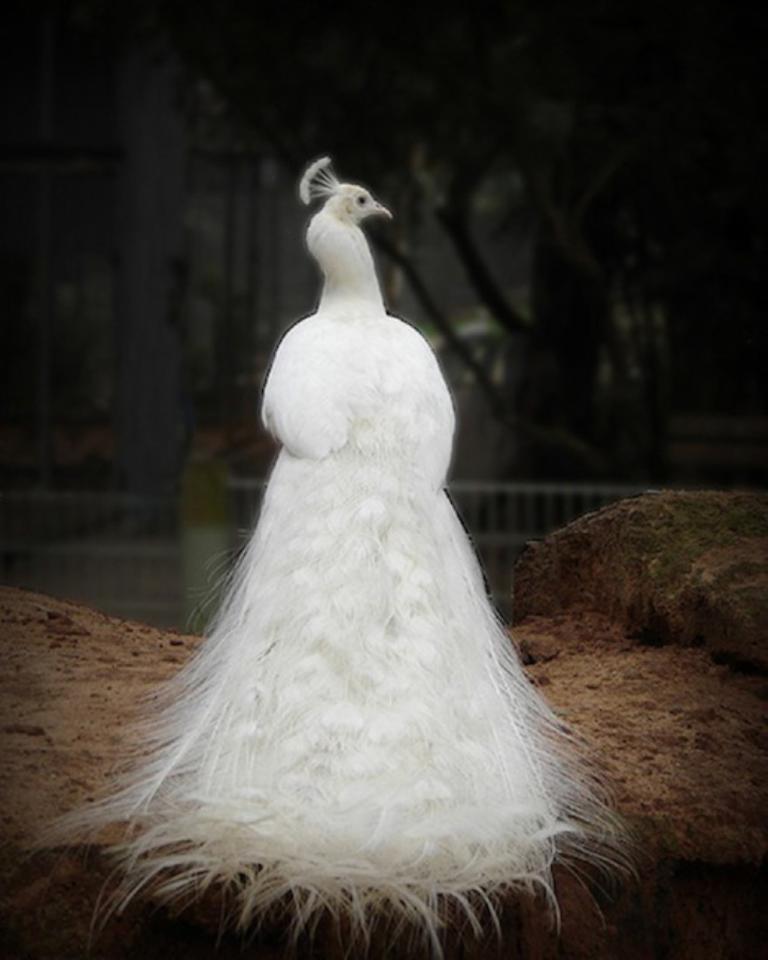In one or two sentences, can you explain what this image depicts? This is a picture of a white peacock , and there is blur background. 